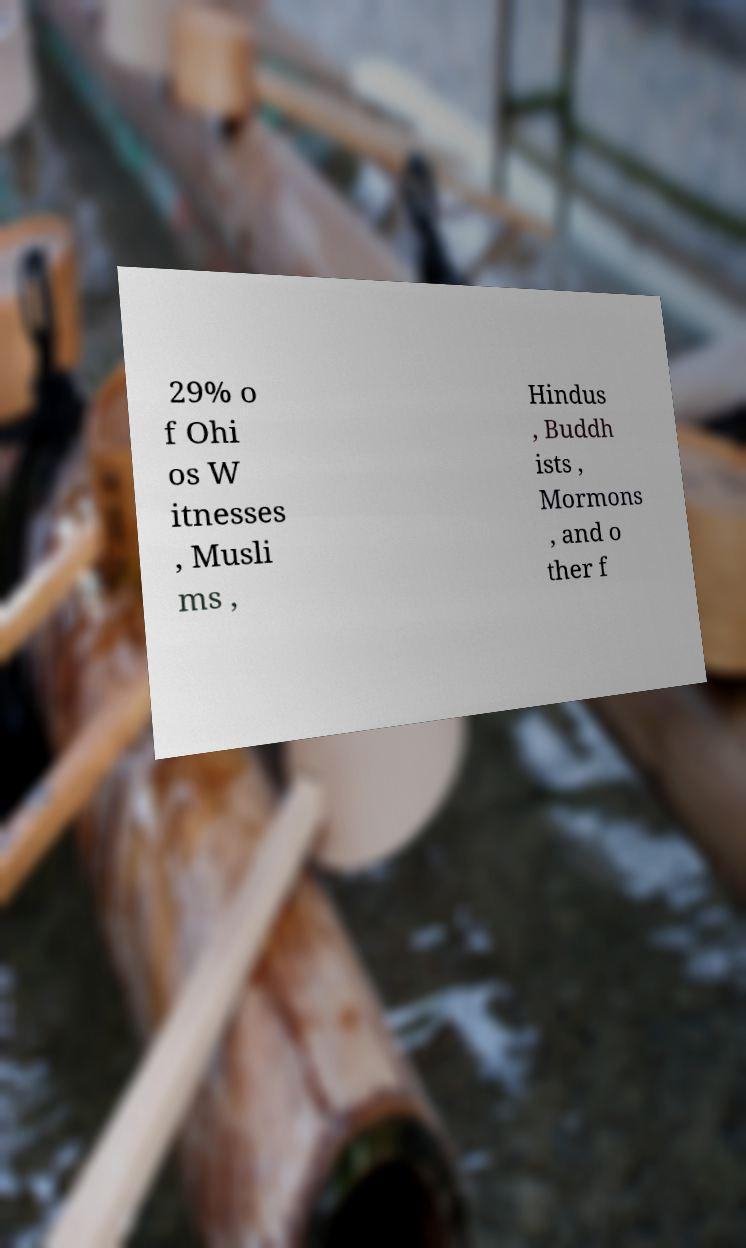Please identify and transcribe the text found in this image. 29% o f Ohi os W itnesses , Musli ms , Hindus , Buddh ists , Mormons , and o ther f 